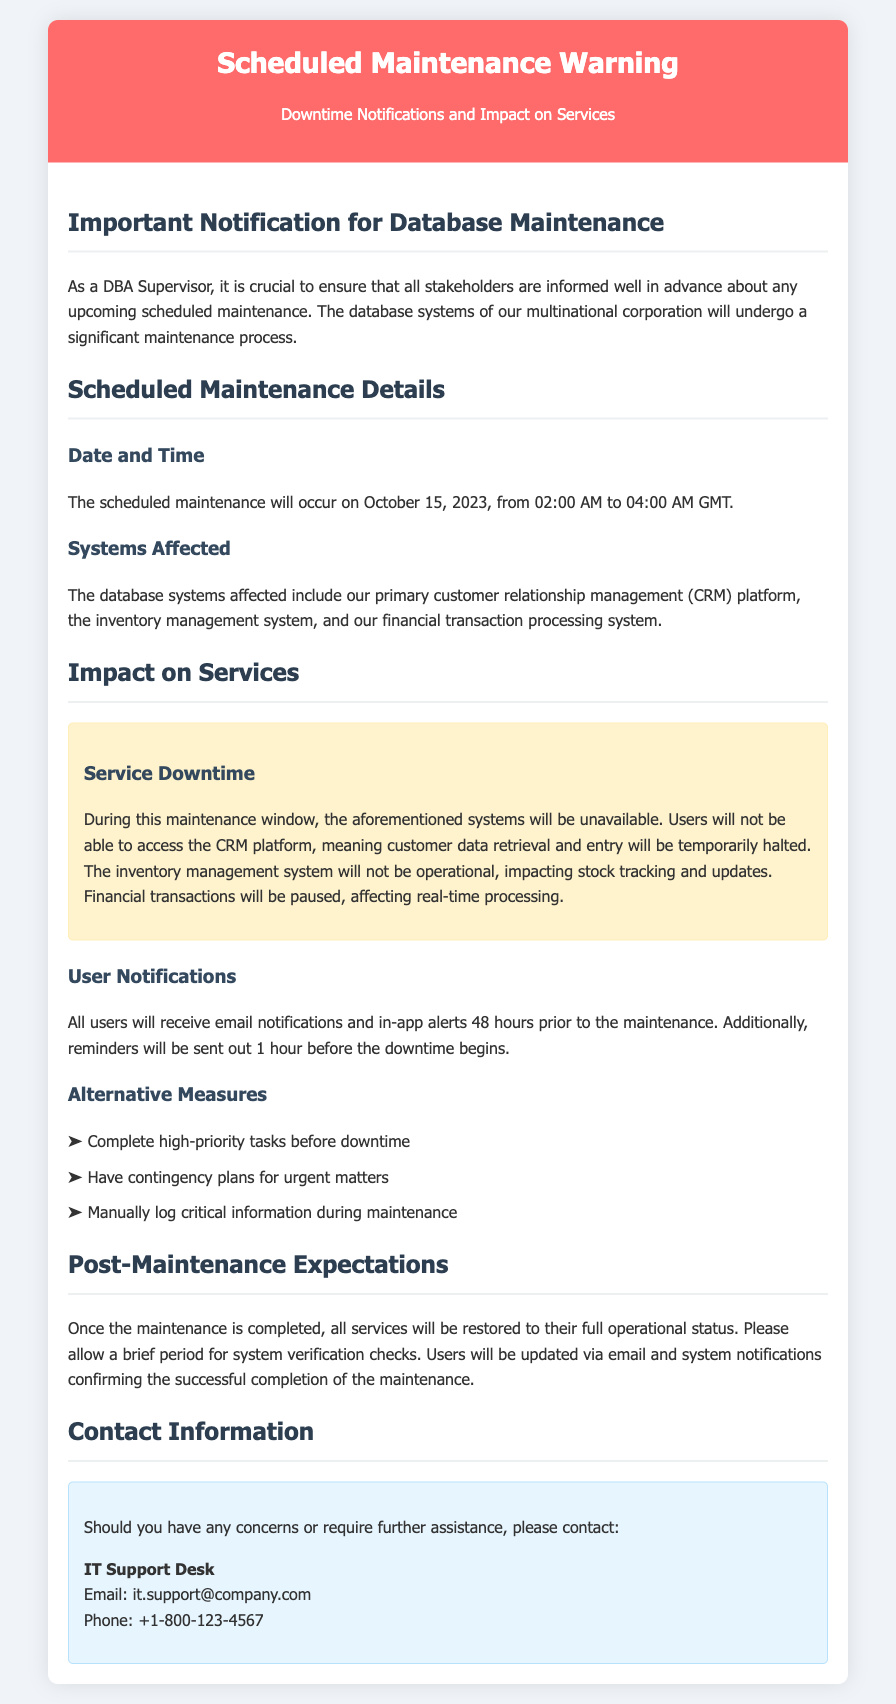What is the scheduled maintenance date? The document specifies the date for the scheduled maintenance as October 15, 2023.
Answer: October 15, 2023 What time will the maintenance occur? The timing for the maintenance is indicated as 02:00 AM to 04:00 AM GMT.
Answer: 02:00 AM to 04:00 AM GMT Which systems are affected by the maintenance? The affected systems listed include the CRM platform, inventory management system, and financial transaction processing system.
Answer: CRM platform, inventory management system, financial transaction processing system What will users receive 48 hours prior to the maintenance? The document states that users will receive email notifications and in-app alerts.
Answer: Email notifications and in-app alerts What is one alternative measure suggested for users? The document lists alternative measures, one of which is to complete high-priority tasks before downtime.
Answer: Complete high-priority tasks before downtime How long will the systems be unavailable during maintenance? The maintenance window indicates system unavailability from 02:00 AM to 04:00 AM GMT, which totals 2 hours.
Answer: 2 hours What will users receive after the maintenance is completed? The document mentions that users will be updated via email and system notifications confirming successful maintenance completion.
Answer: Email and system notifications Who should users contact for assistance? The document provides the contact information for the IT Support Desk for any concerns or further assistance.
Answer: IT Support Desk What type of services will be impacted? The services impacted include customer data retrieval, inventory management, and financial transactions.
Answer: Customer data retrieval, inventory management, financial transactions 